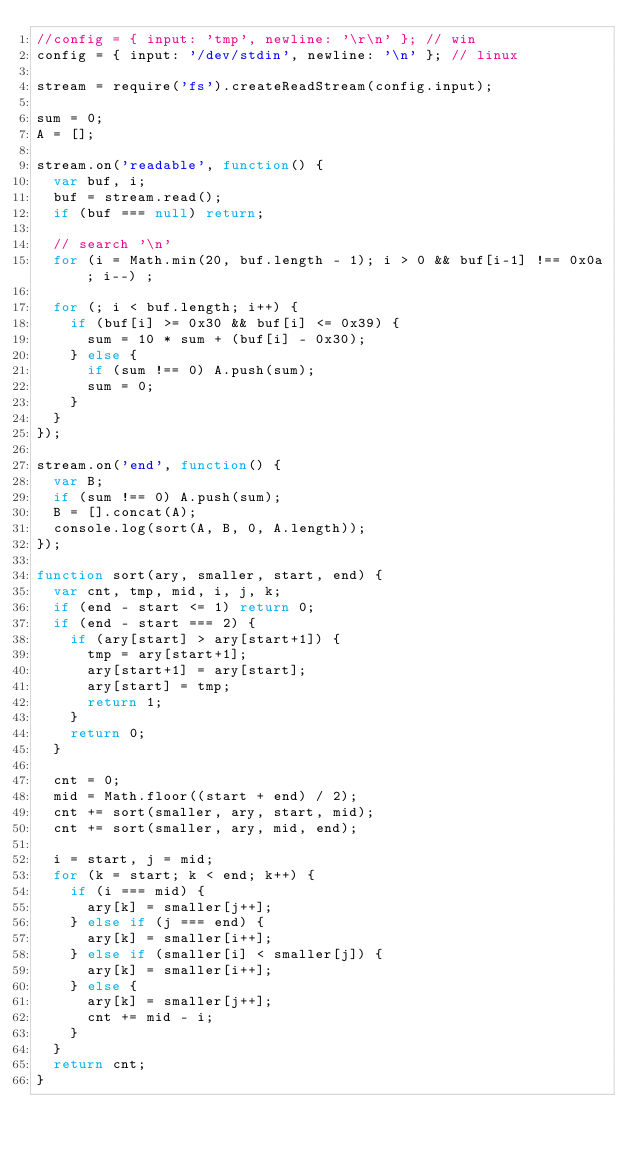Convert code to text. <code><loc_0><loc_0><loc_500><loc_500><_JavaScript_>//config = { input: 'tmp', newline: '\r\n' }; // win
config = { input: '/dev/stdin', newline: '\n' }; // linux

stream = require('fs').createReadStream(config.input);

sum = 0;
A = [];

stream.on('readable', function() {
  var buf, i;
  buf = stream.read();
  if (buf === null) return;

  // search '\n'
  for (i = Math.min(20, buf.length - 1); i > 0 && buf[i-1] !== 0x0a; i--) ;
  
  for (; i < buf.length; i++) {
    if (buf[i] >= 0x30 && buf[i] <= 0x39) {
      sum = 10 * sum + (buf[i] - 0x30);
    } else {
      if (sum !== 0) A.push(sum);
      sum = 0;
    }
  }
});

stream.on('end', function() {
  var B;
  if (sum !== 0) A.push(sum);
  B = [].concat(A);
  console.log(sort(A, B, 0, A.length));
});

function sort(ary, smaller, start, end) {
  var cnt, tmp, mid, i, j, k;
  if (end - start <= 1) return 0;
  if (end - start === 2) {
    if (ary[start] > ary[start+1]) {
      tmp = ary[start+1];
      ary[start+1] = ary[start];
      ary[start] = tmp;
      return 1;
    }
    return 0;
  }

  cnt = 0;
  mid = Math.floor((start + end) / 2);
  cnt += sort(smaller, ary, start, mid);
  cnt += sort(smaller, ary, mid, end);

  i = start, j = mid;
  for (k = start; k < end; k++) {
    if (i === mid) {
      ary[k] = smaller[j++];
    } else if (j === end) {
      ary[k] = smaller[i++];
    } else if (smaller[i] < smaller[j]) {
      ary[k] = smaller[i++];
    } else {
      ary[k] = smaller[j++];
      cnt += mid - i;
    }
  }
  return cnt;
}</code> 